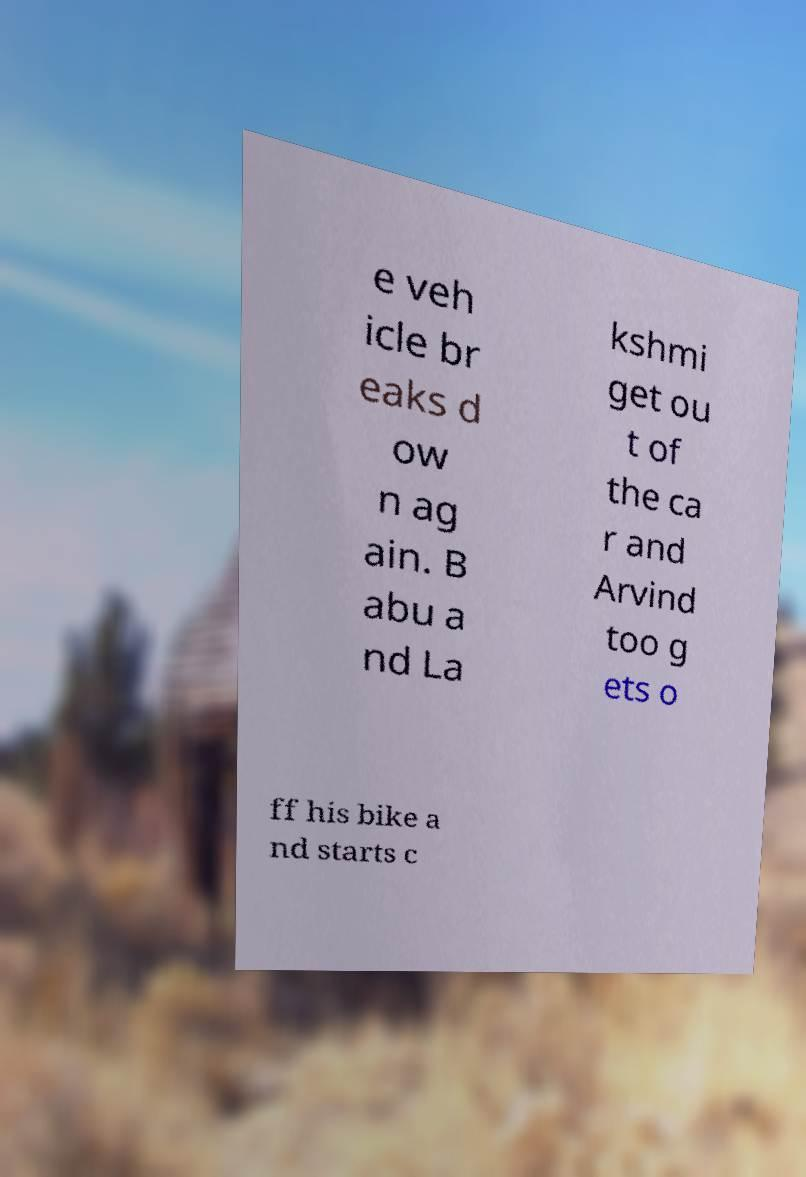Could you assist in decoding the text presented in this image and type it out clearly? e veh icle br eaks d ow n ag ain. B abu a nd La kshmi get ou t of the ca r and Arvind too g ets o ff his bike a nd starts c 